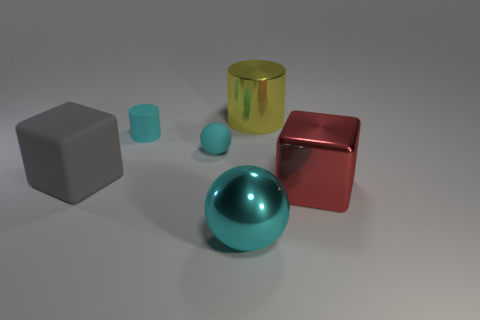There is a large thing that is on the right side of the large yellow cylinder; does it have the same shape as the gray matte thing?
Your response must be concise. Yes. There is a matte thing that is the same color as the small cylinder; what shape is it?
Your answer should be very brief. Sphere. There is a rubber sphere; is it the same color as the sphere that is in front of the gray thing?
Offer a terse response. Yes. Is there a large shiny sphere of the same color as the matte sphere?
Your answer should be compact. Yes. Is the material of the small sphere the same as the cylinder to the left of the metallic ball?
Give a very brief answer. Yes. There is a metallic thing that is the same color as the tiny cylinder; what size is it?
Offer a very short reply. Large. Are there any cyan spheres that have the same material as the large yellow cylinder?
Provide a succinct answer. Yes. How many things are things left of the cyan cylinder or things that are in front of the gray rubber cube?
Ensure brevity in your answer.  3. Does the large cyan thing have the same shape as the rubber thing that is to the right of the small cylinder?
Give a very brief answer. Yes. What number of other objects are the same shape as the red metal object?
Provide a short and direct response. 1. 